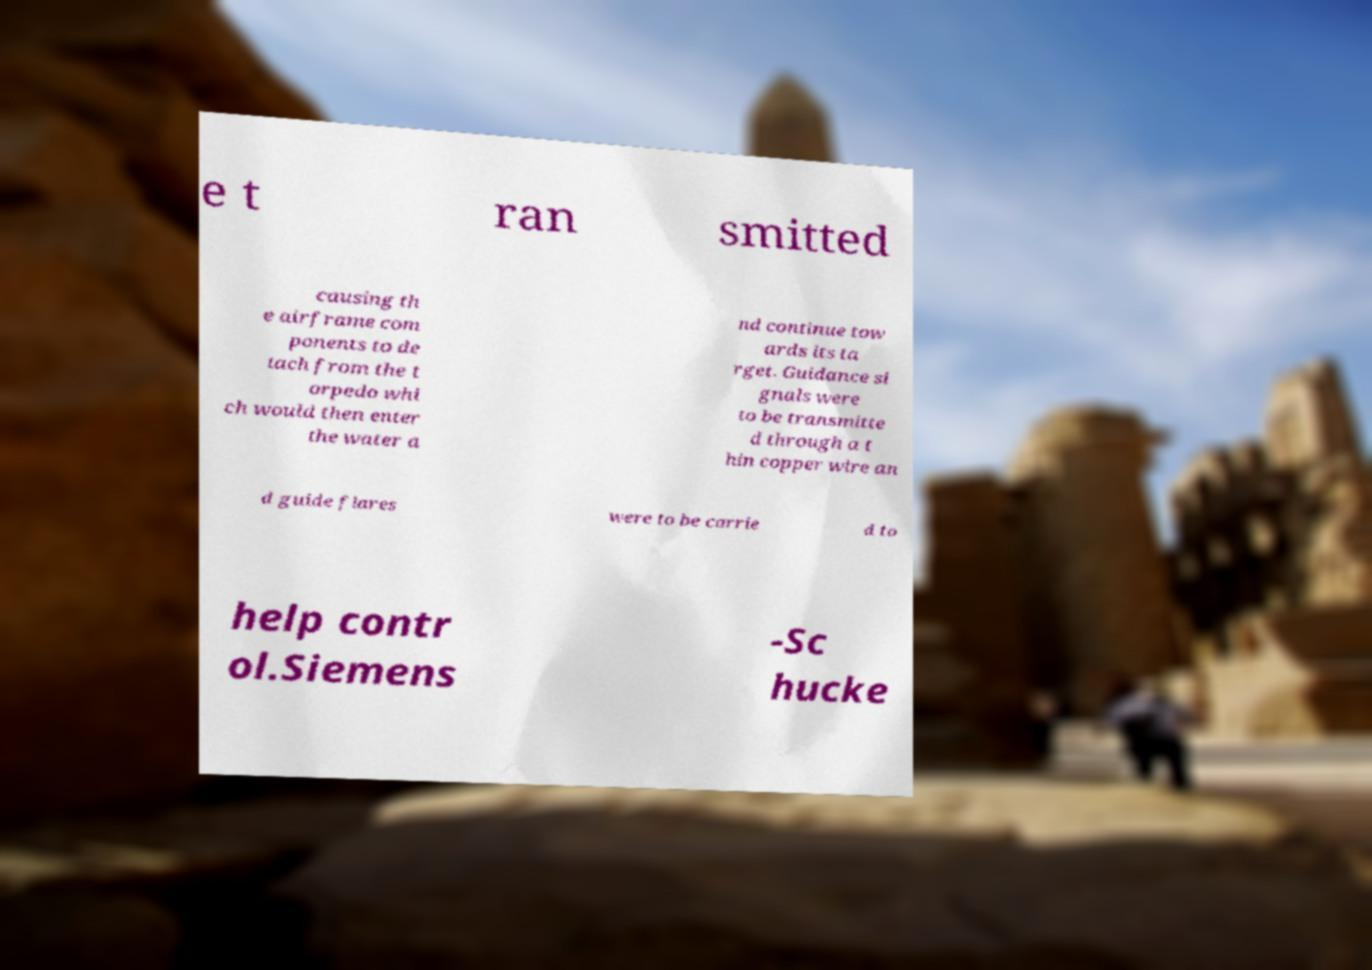Can you read and provide the text displayed in the image?This photo seems to have some interesting text. Can you extract and type it out for me? e t ran smitted causing th e airframe com ponents to de tach from the t orpedo whi ch would then enter the water a nd continue tow ards its ta rget. Guidance si gnals were to be transmitte d through a t hin copper wire an d guide flares were to be carrie d to help contr ol.Siemens -Sc hucke 